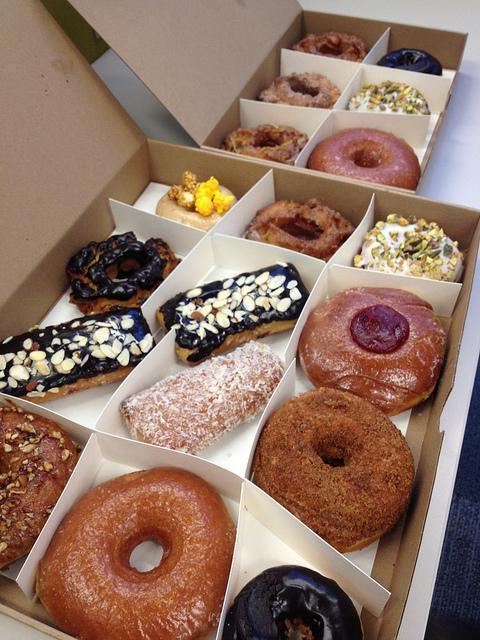What is the most common topping on the frosting?
Answer the question by selecting the correct answer among the 4 following choices.
Options: Popcorn, nuts, jelly, powdered sugar. Nuts. 